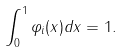<formula> <loc_0><loc_0><loc_500><loc_500>\int _ { 0 } ^ { 1 } { \varphi _ { i } ( x ) d x = 1 } .</formula> 